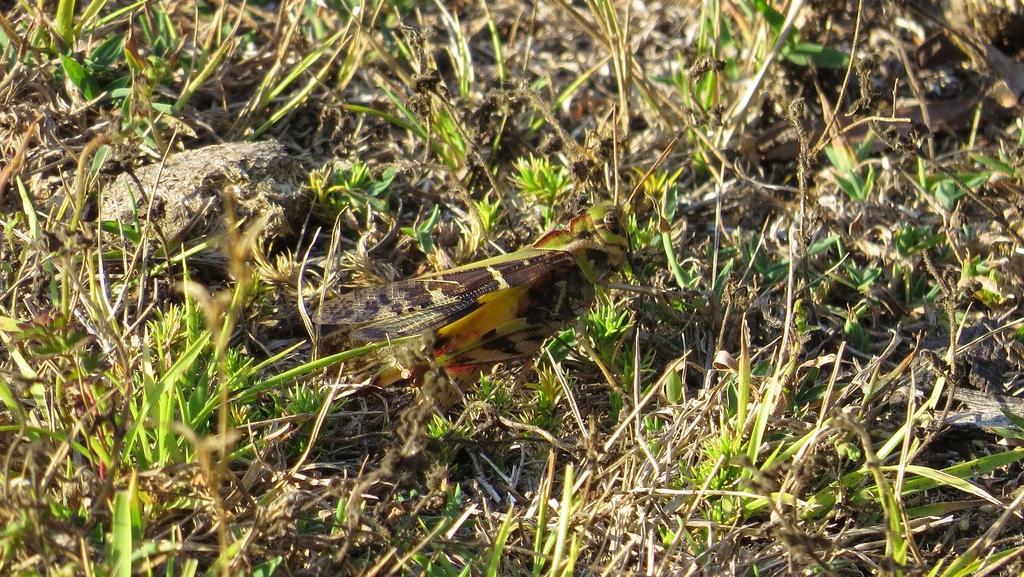How would you summarize this image in a sentence or two? In this image there is an insect on the grass. 